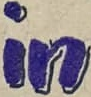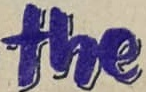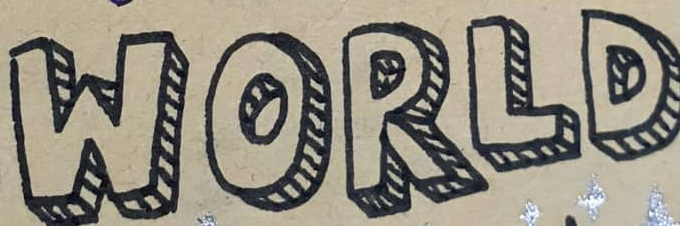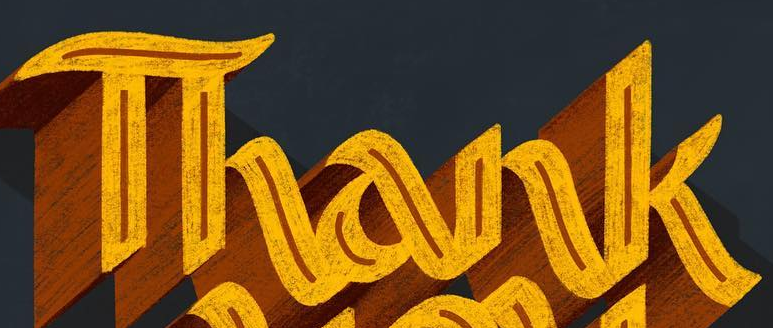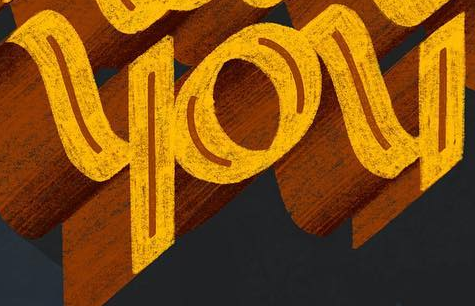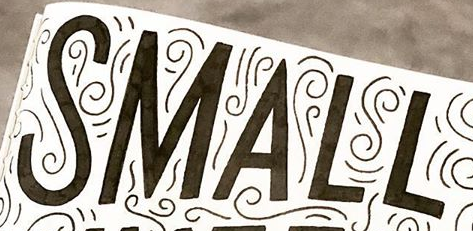What words are shown in these images in order, separated by a semicolon? in; the; WORLD; Thank; you; SMALL 